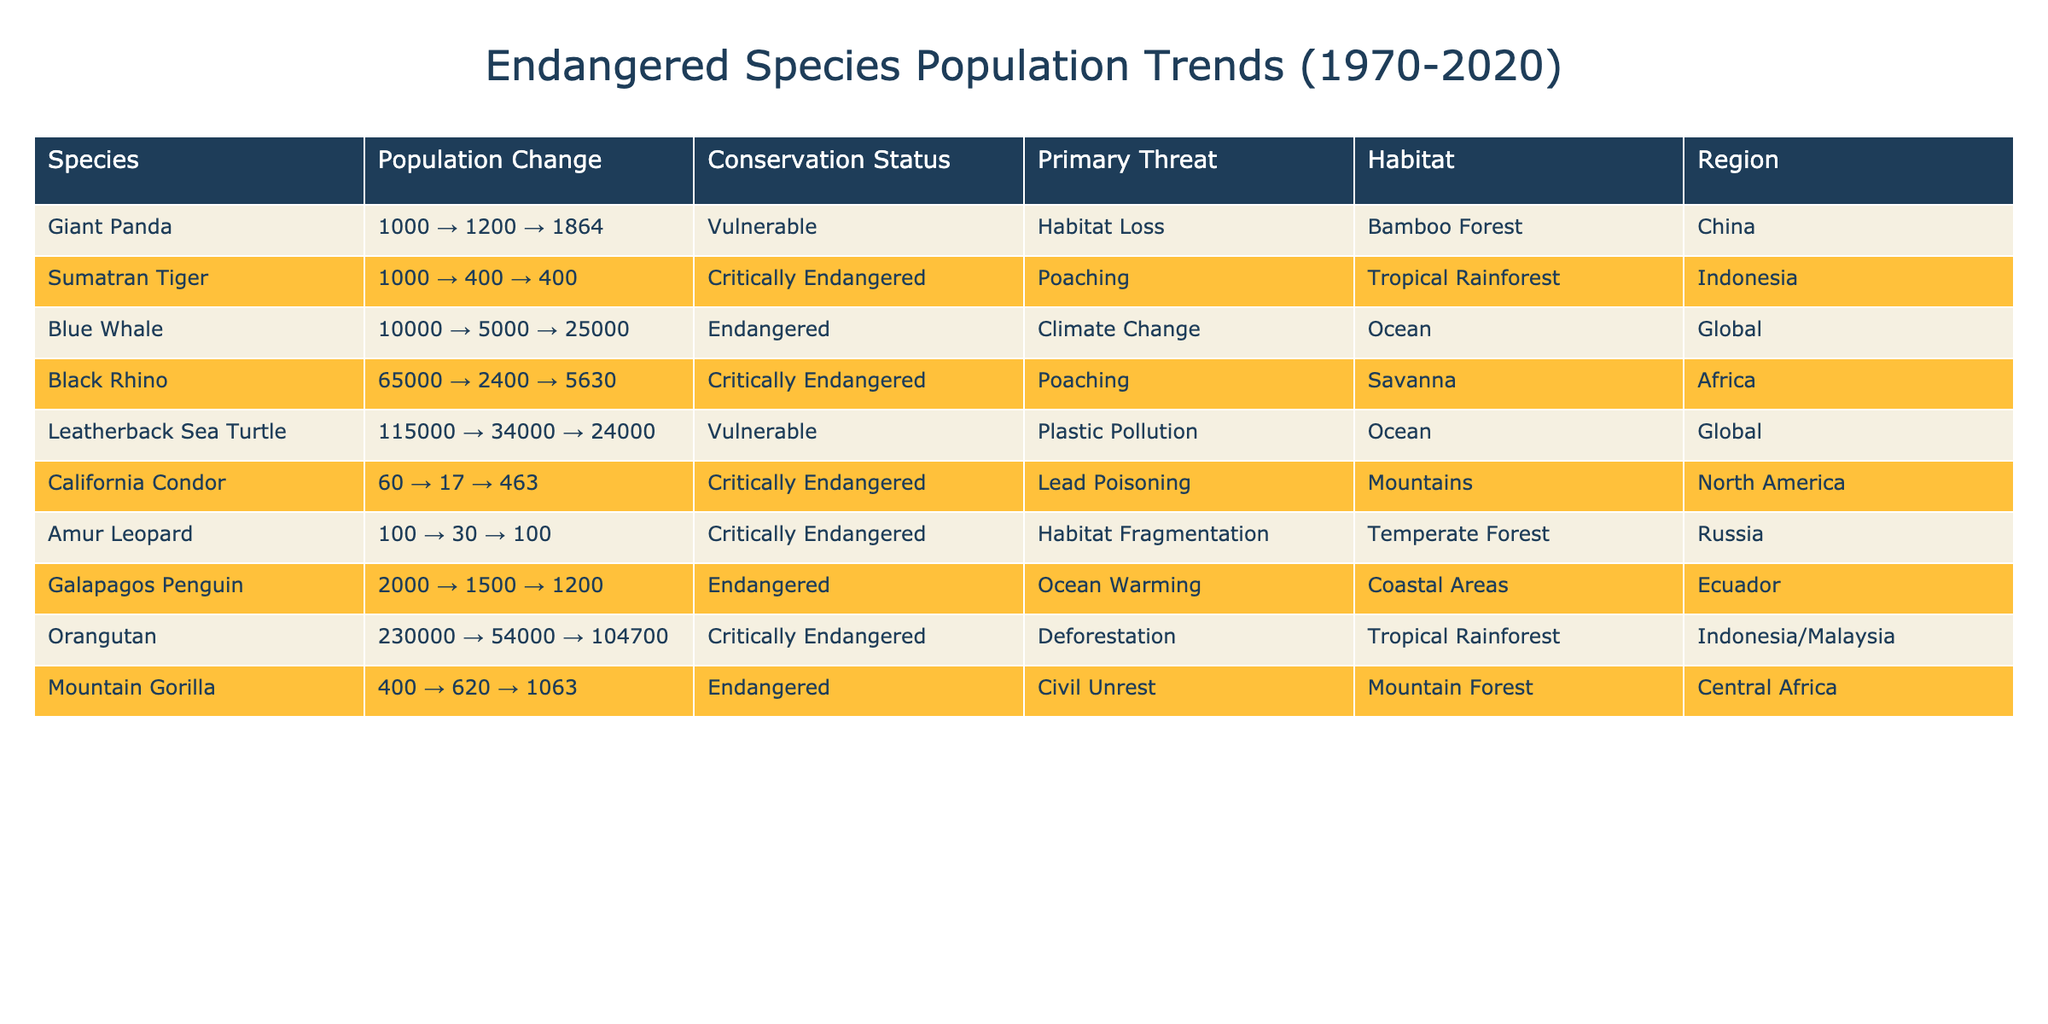What was the population of the Giant Panda in 1995? The table shows that the population of the Giant Panda in 1995 is 1200.
Answer: 1200 Which species had the lowest population in 1970? By comparing the populations listed for 1970, the California Condor had the lowest population of 60.
Answer: California Condor How many species are classified as Critically Endangered? The table lists six species marked as Critically Endangered, namely Sumatran Tiger, Black Rhino, California Condor, Amur Leopard, Orangutan, and Leatherback Sea Turtle.
Answer: Six What is the population change for the Blue Whale from 1995 to 2020? The Blue Whale's population in 1995 was 5000, and it increased to 25000 in 2020; hence, the change is 5000 to 25000.
Answer: 5000 to 25000 Is the population of the Mountain Gorilla higher in 2020 than in 1995? The population of the Mountain Gorilla in 1995 was 620 and increased to 1063 in 2020, so the population is indeed higher in 2020.
Answer: Yes What is the difference in population for the Black Rhino from 1970 to 2020? The population of the Black Rhino decreased from 65000 in 1970 to 5630 in 2020, so the difference is 65000 - 5630 = 59370.
Answer: 59370 Which species has seen a population increase over the past 50 years? The Leatherback Sea Turtle population has decreased from 115000 in 1970 to 24000 in 2020; thus, it experienced a decrease, while the Giant Panda increased from 1000 to 1864, representing growth.
Answer: Giant Panda Are habitat loss and climate change the only primary threats listed? The table indicates that there are multiple primary threats, including poaching, habitat fragmentation, and ocean warming alongside habitat loss and climate change.
Answer: No What is the average population of the Critically Endangered species in 2020? The Critically Endangered species populations in 2020 are 400 (Sumatran Tiger), 5630 (Black Rhino), 463 (California Condor), 100 (Amur Leopard), 104700 (Orangutan). The average is (400 + 5630 + 463 + 100 + 104700) / 5 = 21166.6.
Answer: Approximately 21167 Which region is home to the most Critically Endangered species listed? The table shows that both Africa and Indonesia have multiple Critically Endangered species, but Indonesia is home to the Sumatran Tiger and Orangutan, while Africa has the Black Rhino.
Answer: Indonesia and Africa (tie) 